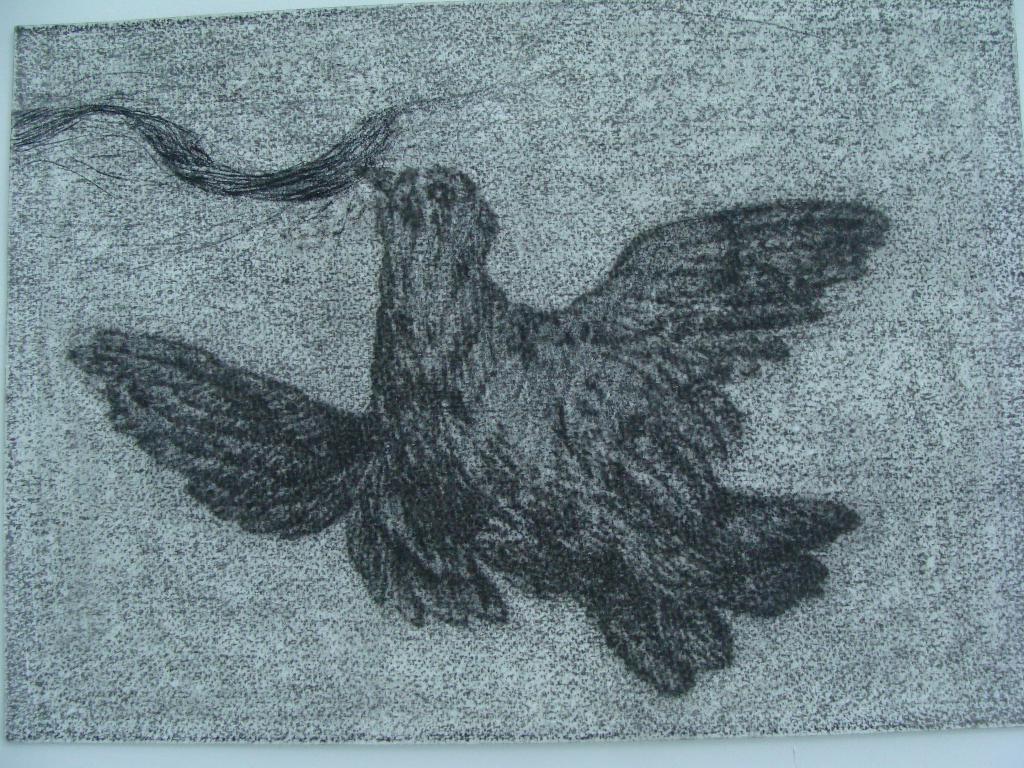Describe this image in one or two sentences. In this image we can see a sketch art of a bird which is placed on a white surface. 